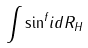<formula> <loc_0><loc_0><loc_500><loc_500>\int { \sin } ^ { f } i d { R } _ { H }</formula> 